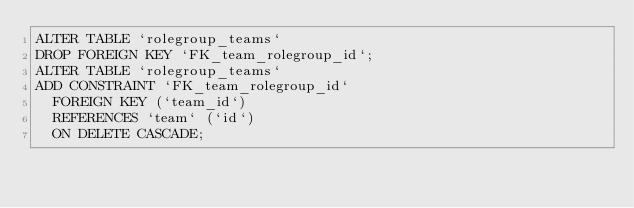Convert code to text. <code><loc_0><loc_0><loc_500><loc_500><_SQL_>ALTER TABLE `rolegroup_teams`
DROP FOREIGN KEY `FK_team_rolegroup_id`;
ALTER TABLE `rolegroup_teams`
ADD CONSTRAINT `FK_team_rolegroup_id`
  FOREIGN KEY (`team_id`)
  REFERENCES `team` (`id`)
  ON DELETE CASCADE;
</code> 